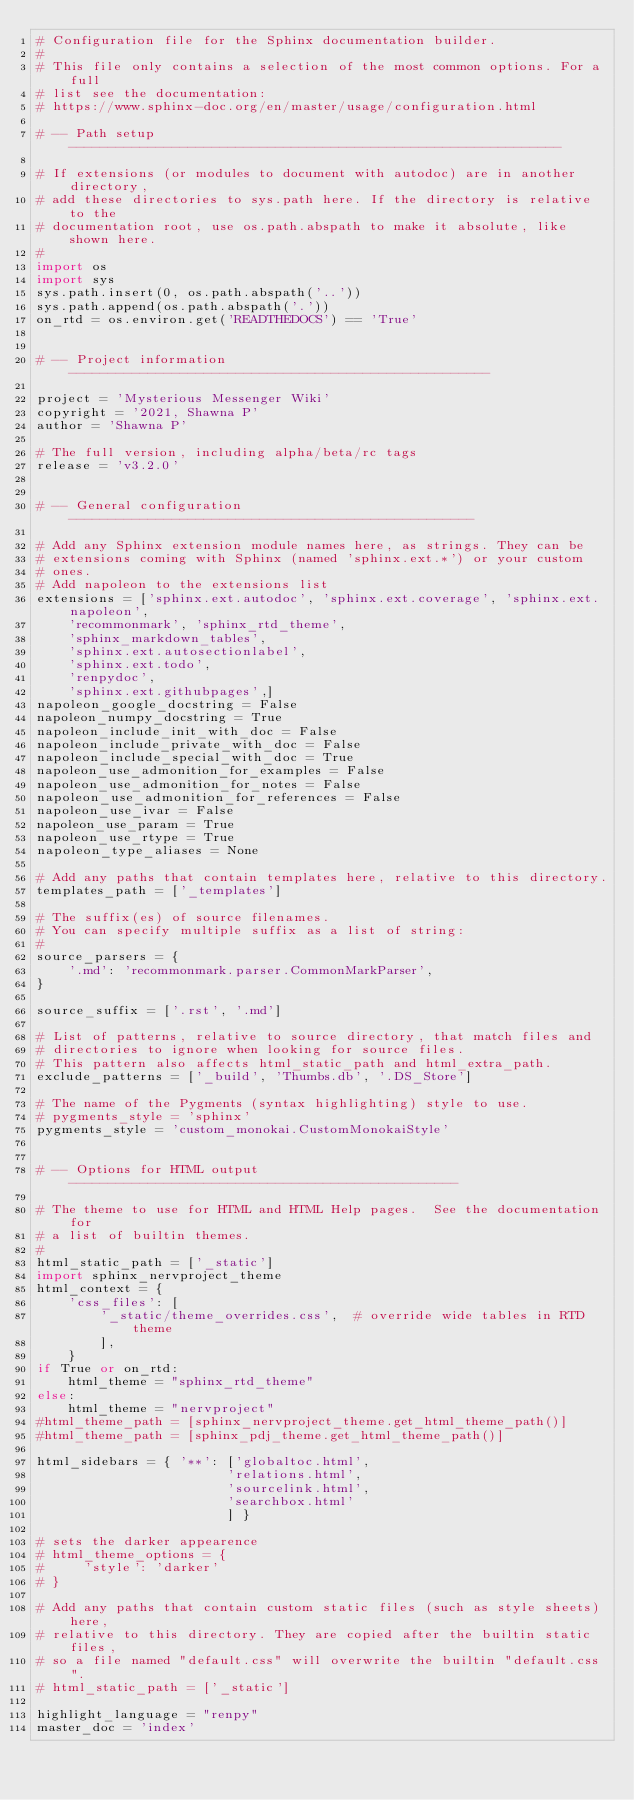<code> <loc_0><loc_0><loc_500><loc_500><_Python_># Configuration file for the Sphinx documentation builder.
#
# This file only contains a selection of the most common options. For a full
# list see the documentation:
# https://www.sphinx-doc.org/en/master/usage/configuration.html

# -- Path setup --------------------------------------------------------------

# If extensions (or modules to document with autodoc) are in another directory,
# add these directories to sys.path here. If the directory is relative to the
# documentation root, use os.path.abspath to make it absolute, like shown here.
#
import os
import sys
sys.path.insert(0, os.path.abspath('..'))
sys.path.append(os.path.abspath('.'))
on_rtd = os.environ.get('READTHEDOCS') == 'True'


# -- Project information -----------------------------------------------------

project = 'Mysterious Messenger Wiki'
copyright = '2021, Shawna P'
author = 'Shawna P'

# The full version, including alpha/beta/rc tags
release = 'v3.2.0'


# -- General configuration ---------------------------------------------------

# Add any Sphinx extension module names here, as strings. They can be
# extensions coming with Sphinx (named 'sphinx.ext.*') or your custom
# ones.
# Add napoleon to the extensions list
extensions = ['sphinx.ext.autodoc', 'sphinx.ext.coverage', 'sphinx.ext.napoleon',
    'recommonmark', 'sphinx_rtd_theme',
    'sphinx_markdown_tables',
    'sphinx.ext.autosectionlabel',
    'sphinx.ext.todo',
    'renpydoc',
    'sphinx.ext.githubpages',]
napoleon_google_docstring = False
napoleon_numpy_docstring = True
napoleon_include_init_with_doc = False
napoleon_include_private_with_doc = False
napoleon_include_special_with_doc = True
napoleon_use_admonition_for_examples = False
napoleon_use_admonition_for_notes = False
napoleon_use_admonition_for_references = False
napoleon_use_ivar = False
napoleon_use_param = True
napoleon_use_rtype = True
napoleon_type_aliases = None

# Add any paths that contain templates here, relative to this directory.
templates_path = ['_templates']

# The suffix(es) of source filenames.
# You can specify multiple suffix as a list of string:
#
source_parsers = {
    '.md': 'recommonmark.parser.CommonMarkParser',
}

source_suffix = ['.rst', '.md']

# List of patterns, relative to source directory, that match files and
# directories to ignore when looking for source files.
# This pattern also affects html_static_path and html_extra_path.
exclude_patterns = ['_build', 'Thumbs.db', '.DS_Store']

# The name of the Pygments (syntax highlighting) style to use.
# pygments_style = 'sphinx'
pygments_style = 'custom_monokai.CustomMonokaiStyle'


# -- Options for HTML output -------------------------------------------------

# The theme to use for HTML and HTML Help pages.  See the documentation for
# a list of builtin themes.
#
html_static_path = ['_static']
import sphinx_nervproject_theme
html_context = {
    'css_files': [
        '_static/theme_overrides.css',  # override wide tables in RTD theme
        ],
    }
if True or on_rtd:
    html_theme = "sphinx_rtd_theme"
else:
    html_theme = "nervproject"
#html_theme_path = [sphinx_nervproject_theme.get_html_theme_path()]
#html_theme_path = [sphinx_pdj_theme.get_html_theme_path()]

html_sidebars = { '**': ['globaltoc.html',
                        'relations.html',
                        'sourcelink.html',
                        'searchbox.html'
                        ] }

# sets the darker appearence
# html_theme_options = {
#     'style': 'darker'
# }

# Add any paths that contain custom static files (such as style sheets) here,
# relative to this directory. They are copied after the builtin static files,
# so a file named "default.css" will overwrite the builtin "default.css".
# html_static_path = ['_static']

highlight_language = "renpy"
master_doc = 'index'</code> 